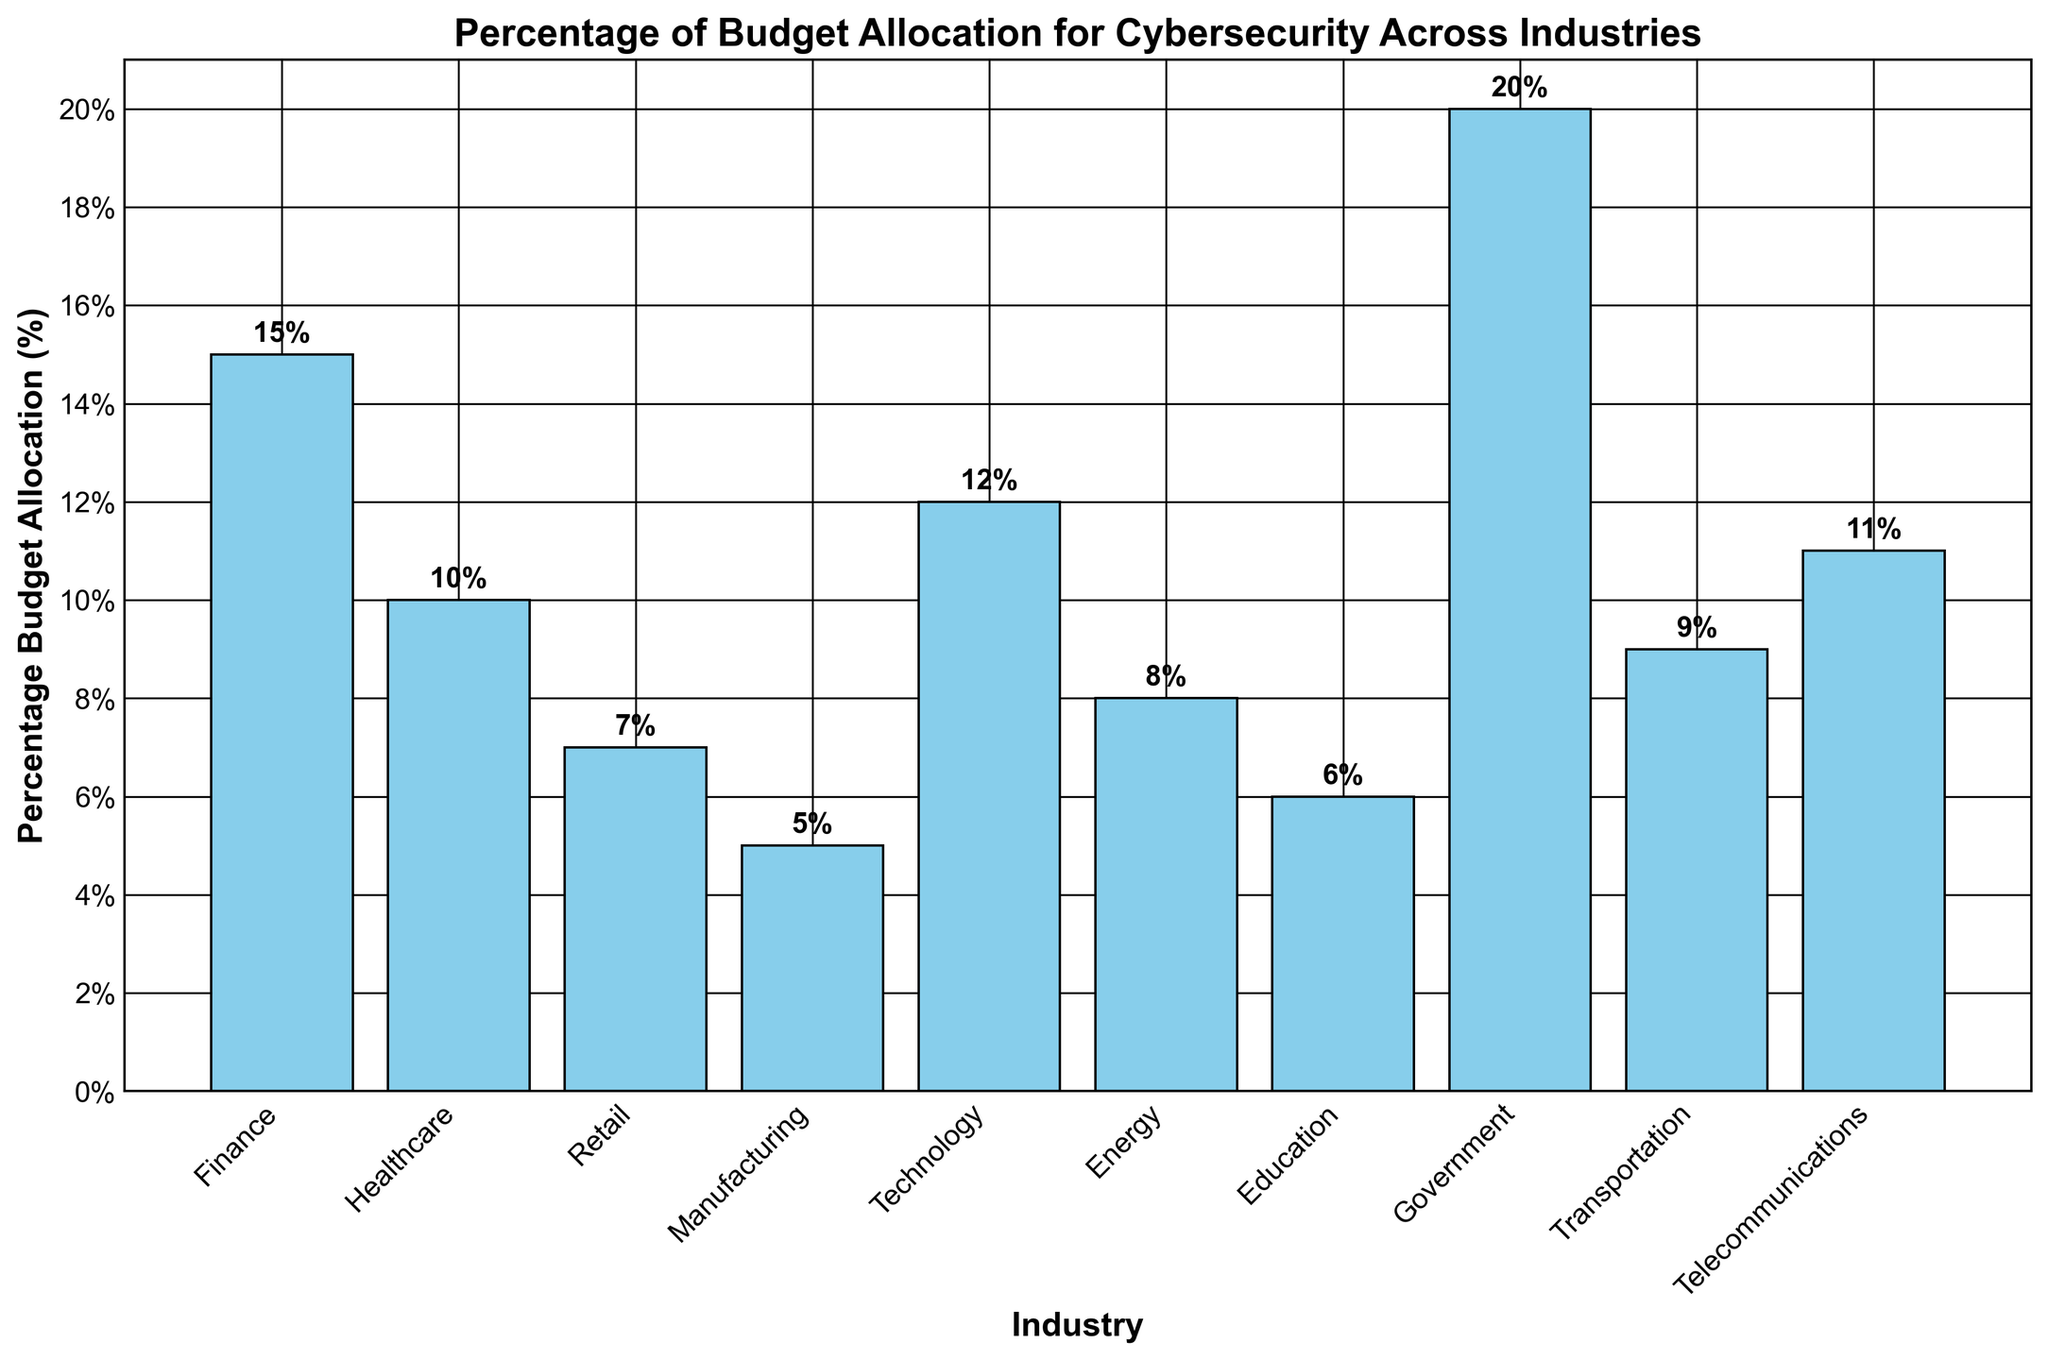Which industry allocates the highest percentage of its budget to cybersecurity? By observing the heights of the bars, the Government industry has the tallest bar, indicating it allocates the highest percentage.
Answer: Government Which two industries have the smallest percentage of their budget allocated to cybersecurity? By checking the shortest bars, Manufacturing and Education have the lowest bars, indicating they allocate the smallest percentage.
Answer: Manufacturing, Education What is the combined percentage of budget allocation for the Healthcare and Energy industries? Healthcare allocates 10%, and Energy allocates 8%. Summing these gives 10% + 8% = 18%.
Answer: 18% Is the percentage budget allocation for the Finance industry higher than that of the Technology industry? Comparing the heights of the Finance and Technology bars, Finance allocates 15% while Technology allocates 12%. Thus, the Finance industry's allocation is higher.
Answer: Yes How much greater is the Government's budget allocation compared to Retail's? Government allocates 20%, and Retail allocates 7%. The difference is 20% - 7% = 13%.
Answer: 13% Which industries have a budget allocation percentage greater than 10%? Identifying bars higher than the 10% mark, the industries are Finance (15%), Technology (12%), Telecommunications (11%), and Government (20%).
Answer: Finance, Technology, Telecommunications, Government What is the average percentage budget allocation for all industries? Sum all the percentages (15 + 10 + 7 + 5 + 12 + 8 + 6 + 20 + 9 + 11) = 103. There are 10 industries, so the average is 103 / 10 = 10.3%.
Answer: 10.3% Is the cybersecurity budget allocation for the Transportation industry greater or less than that for the Healthcare industry? Comparing the heights of the Transportation (9%) and Healthcare (10%) bars shows that the Transportation industry's allocation is less.
Answer: Less What is the total budget allocation for Finance, Healthcare, and Technology industries combined? Summing the percentages for Finance (15%), Healthcare (10%), and Technology (12%) gives 15 + 10 + 12 = 37.
Answer: 37% 